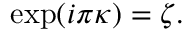<formula> <loc_0><loc_0><loc_500><loc_500>\exp ( i \pi \kappa ) = \zeta .</formula> 